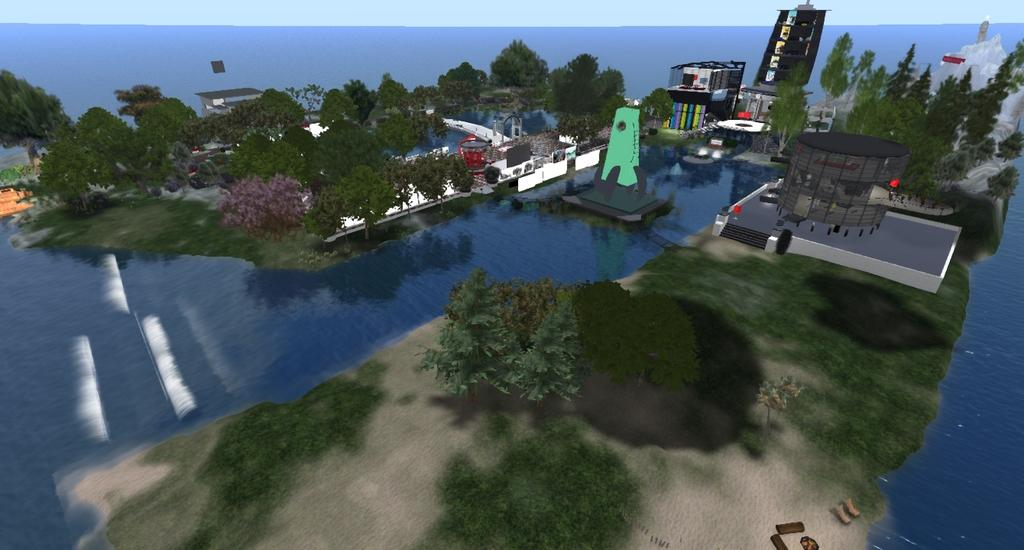What type of visual elements can be seen in the image? There are graphics, trees, buildings, and grass on the land in the image. What natural elements are present in the image? There are trees and an ocean in the background of the image. What is visible in the sky in the image? There is a sky visible in the background of the image. How many candles are on the birthday cake in the image? There is no birthday cake present in the image. What type of maid is cleaning the grass in the image? There is no maid present in the image, and the grass is not being cleaned. 